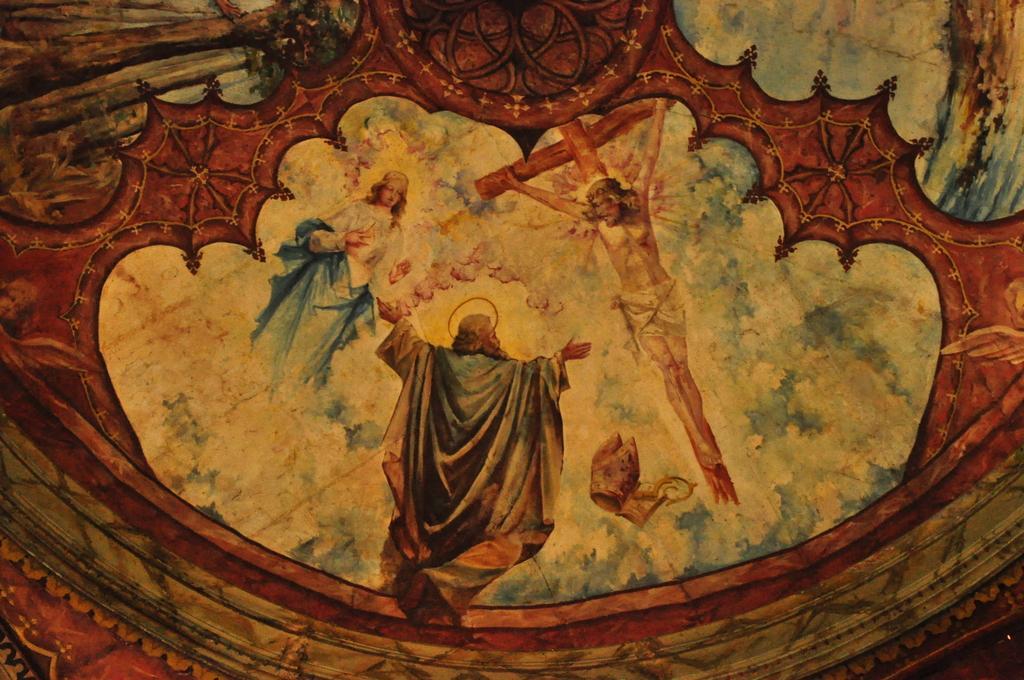Describe this image in one or two sentences. In the image we can see there is a painting and there are people flying in the sky. There is a person standing on the cross and there is a cloudy sky. 